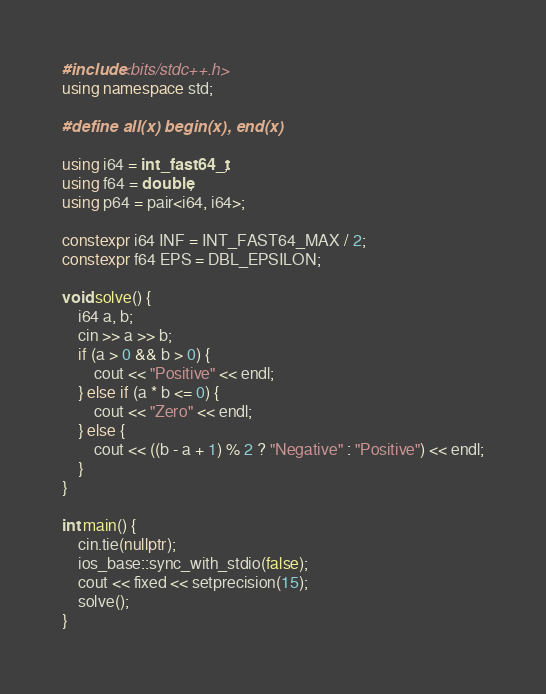Convert code to text. <code><loc_0><loc_0><loc_500><loc_500><_C++_>#include<bits/stdc++.h>
using namespace std;

#define all(x) begin(x), end(x)

using i64 = int_fast64_t;
using f64 = double;
using p64 = pair<i64, i64>;

constexpr i64 INF = INT_FAST64_MAX / 2;
constexpr f64 EPS = DBL_EPSILON;

void solve() {
    i64 a, b;
    cin >> a >> b;
    if (a > 0 && b > 0) {
        cout << "Positive" << endl;
    } else if (a * b <= 0) {
        cout << "Zero" << endl;
    } else {
        cout << ((b - a + 1) % 2 ? "Negative" : "Positive") << endl;
    }
}

int main() {
    cin.tie(nullptr);
    ios_base::sync_with_stdio(false);
    cout << fixed << setprecision(15);
    solve();
}
</code> 